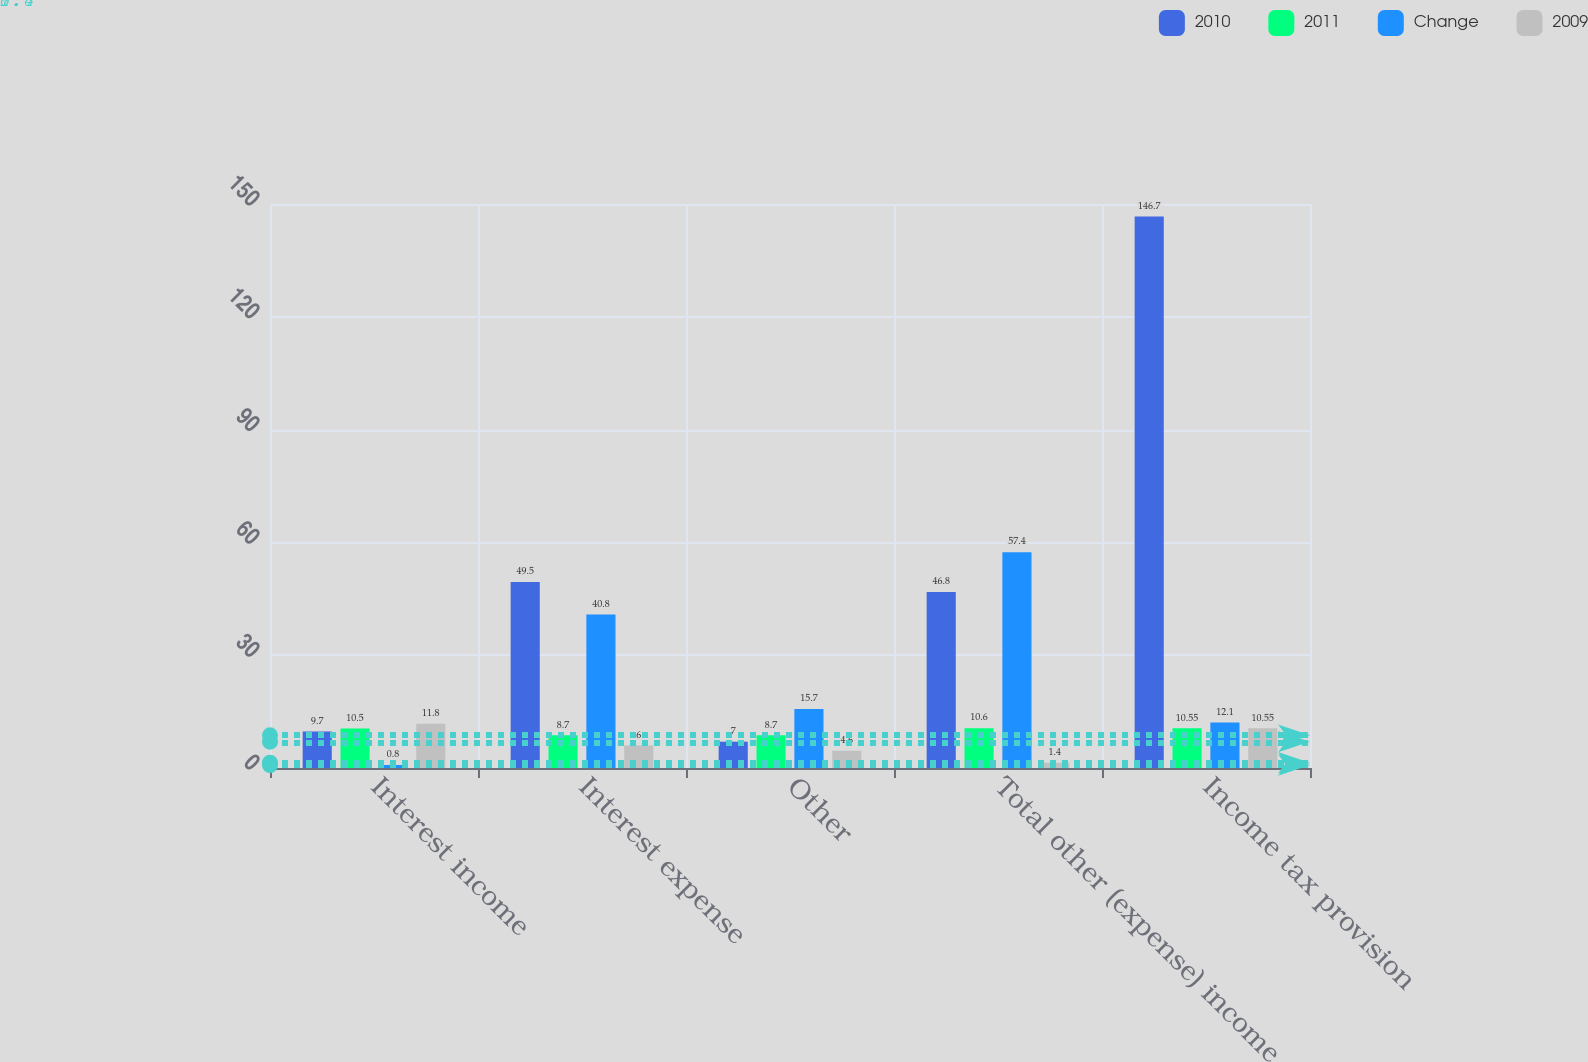Convert chart to OTSL. <chart><loc_0><loc_0><loc_500><loc_500><stacked_bar_chart><ecel><fcel>Interest income<fcel>Interest expense<fcel>Other<fcel>Total other (expense) income<fcel>Income tax provision<nl><fcel>2010<fcel>9.7<fcel>49.5<fcel>7<fcel>46.8<fcel>146.7<nl><fcel>2011<fcel>10.5<fcel>8.7<fcel>8.7<fcel>10.6<fcel>10.55<nl><fcel>Change<fcel>0.8<fcel>40.8<fcel>15.7<fcel>57.4<fcel>12.1<nl><fcel>2009<fcel>11.8<fcel>6<fcel>4.6<fcel>1.4<fcel>10.55<nl></chart> 